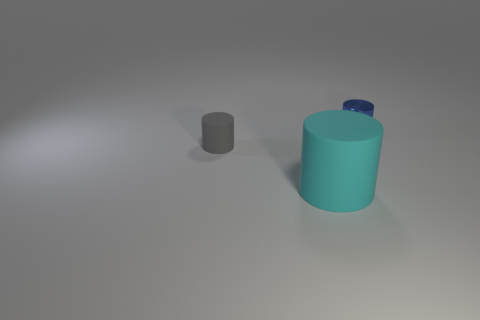Subtract all gray cylinders. How many cylinders are left? 2 Subtract all yellow cylinders. Subtract all red blocks. How many cylinders are left? 3 Add 1 red rubber cubes. How many objects exist? 4 Add 3 big cyan matte things. How many big cyan matte things are left? 4 Add 3 small red blocks. How many small red blocks exist? 3 Subtract 0 blue cubes. How many objects are left? 3 Subtract all tiny cyan rubber blocks. Subtract all tiny blue shiny objects. How many objects are left? 2 